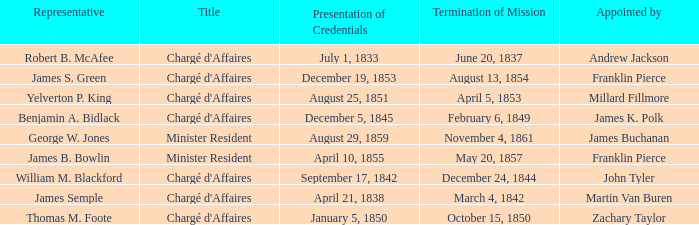What Title has a Termination of Mission for August 13, 1854? Chargé d'Affaires. 